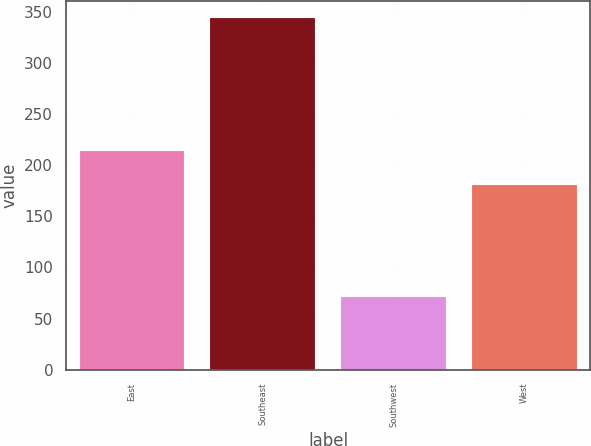Convert chart. <chart><loc_0><loc_0><loc_500><loc_500><bar_chart><fcel>East<fcel>Southeast<fcel>Southwest<fcel>West<nl><fcel>214<fcel>344<fcel>71<fcel>181<nl></chart> 